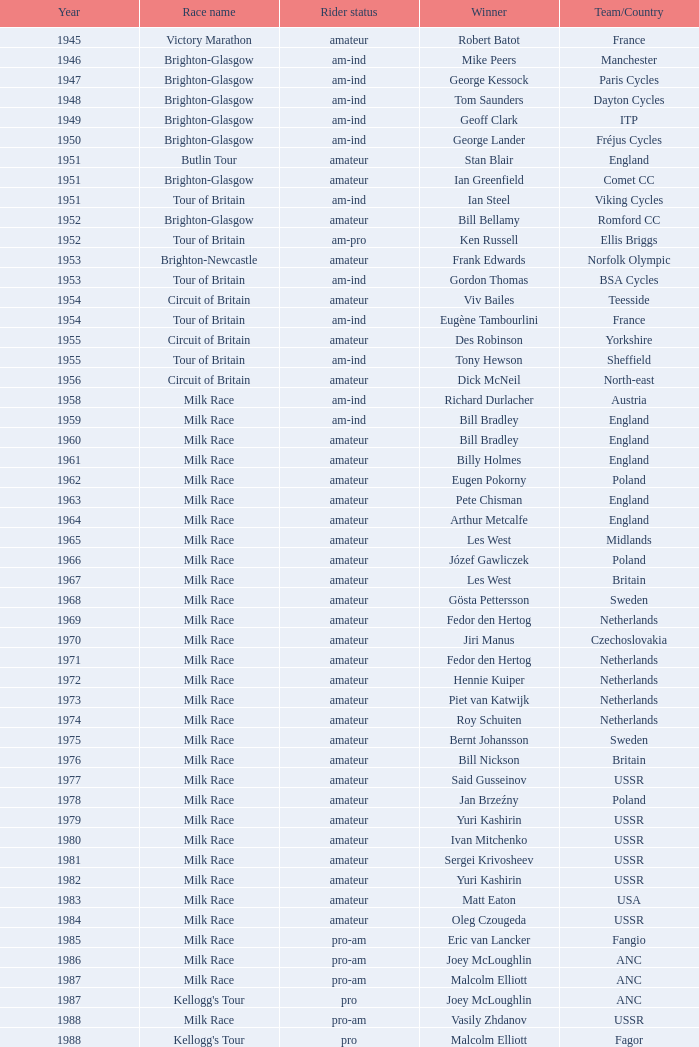Who claimed victory as an amateur rider in 1973? Piet van Katwijk. 